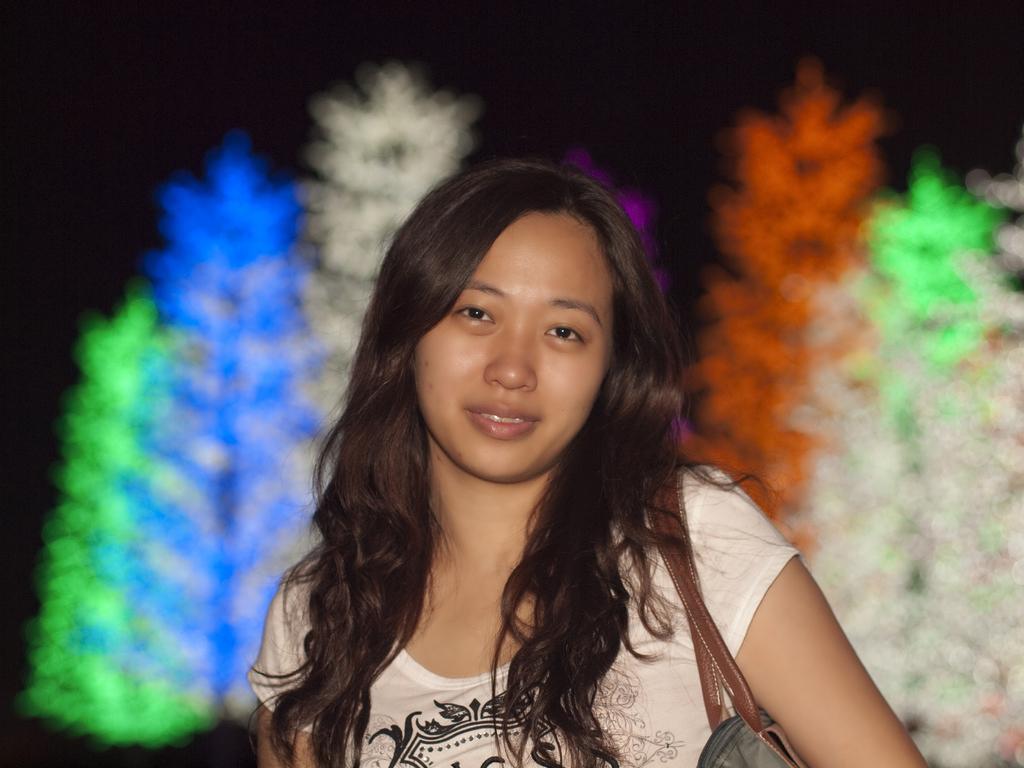Could you give a brief overview of what you see in this image? In this image we can see a woman is standing, she is wearing the white t-shirt, the background is blurry. 